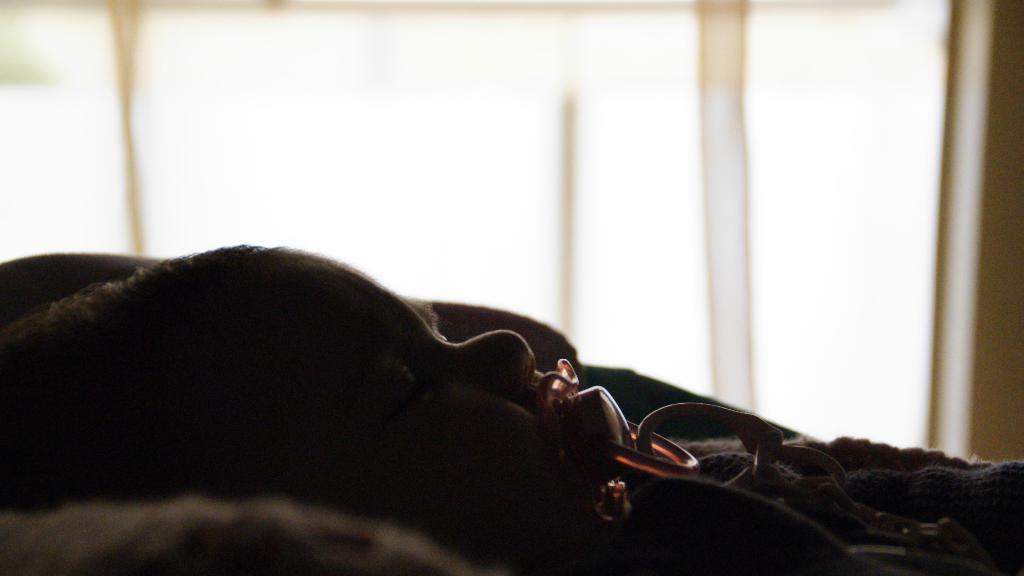What is the main subject of the image? There is a baby in the image. What is the baby doing in the image? The baby has an object in her mouth. What is the color of the background in the image? The background of the image is white. What type of beef is the baby holding in the image? There is no beef present in the image; the baby has an object in her mouth, but it is not specified as beef. 